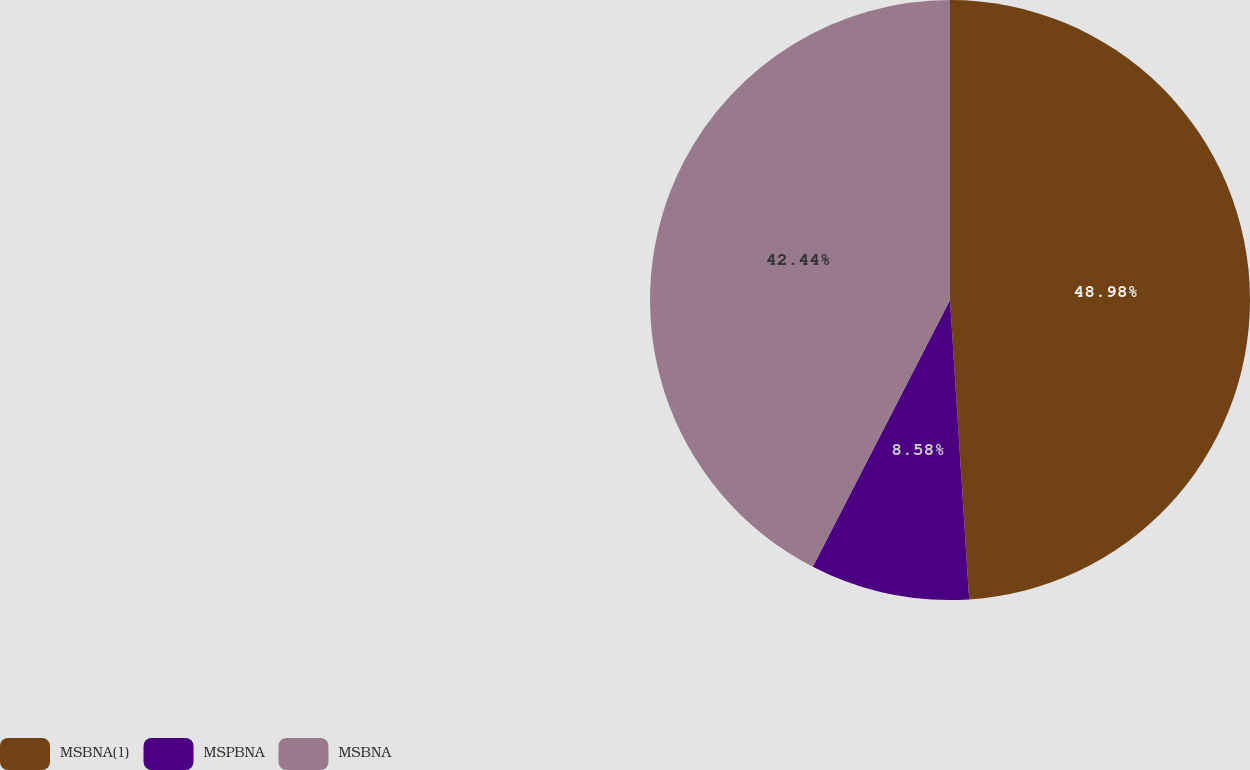Convert chart. <chart><loc_0><loc_0><loc_500><loc_500><pie_chart><fcel>MSBNA(1)<fcel>MSPBNA<fcel>MSBNA<nl><fcel>48.98%<fcel>8.58%<fcel>42.44%<nl></chart> 